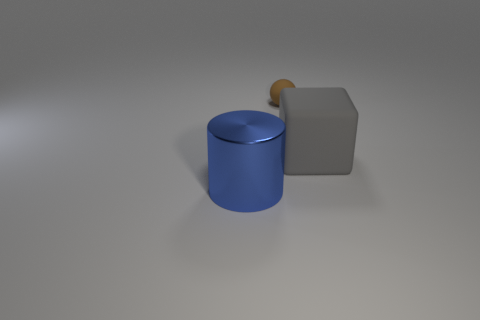Add 3 large metallic balls. How many objects exist? 6 Subtract all spheres. How many objects are left? 2 Add 2 big cyan cylinders. How many big cyan cylinders exist? 2 Subtract 0 gray cylinders. How many objects are left? 3 Subtract 1 cubes. How many cubes are left? 0 Subtract all brown cylinders. Subtract all brown cubes. How many cylinders are left? 1 Subtract all blue metallic cylinders. Subtract all small brown spheres. How many objects are left? 1 Add 3 big gray cubes. How many big gray cubes are left? 4 